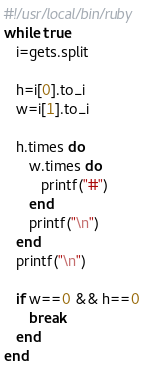Convert code to text. <code><loc_0><loc_0><loc_500><loc_500><_Ruby_>#!/usr/local/bin/ruby
while true
   i=gets.split
   
   h=i[0].to_i
   w=i[1].to_i
   
   h.times do
      w.times do
         printf("#")
      end
      printf("\n")
   end
   printf("\n")

   if w==0 && h==0
      break
   end
end</code> 